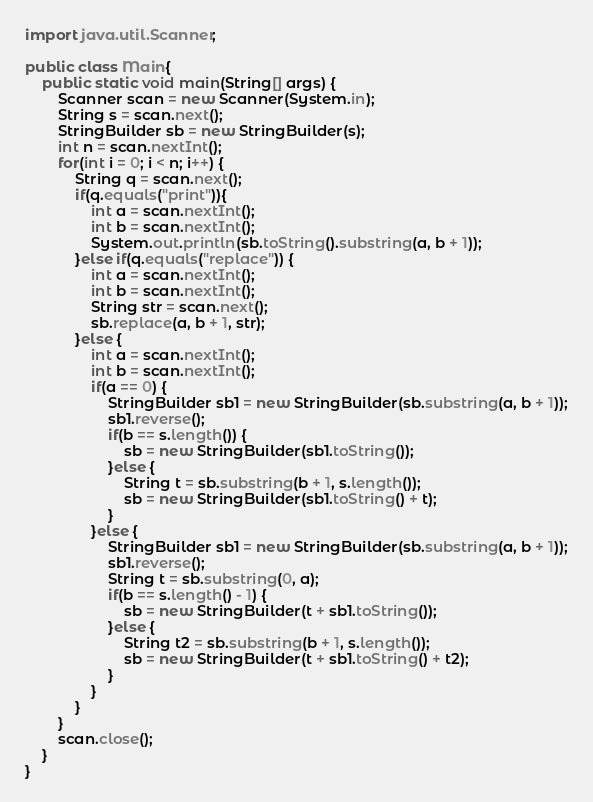Convert code to text. <code><loc_0><loc_0><loc_500><loc_500><_Java_>import java.util.Scanner;

public class Main{
	public static void main(String[] args) {
		Scanner scan = new Scanner(System.in);
		String s = scan.next();
		StringBuilder sb = new StringBuilder(s);
		int n = scan.nextInt();
		for(int i = 0; i < n; i++) {
			String q = scan.next();
			if(q.equals("print")){
				int a = scan.nextInt();
				int b = scan.nextInt();
				System.out.println(sb.toString().substring(a, b + 1));
			}else if(q.equals("replace")) {
				int a = scan.nextInt();
				int b = scan.nextInt();
				String str = scan.next();
				sb.replace(a, b + 1, str);
			}else {
				int a = scan.nextInt();
				int b = scan.nextInt();
				if(a == 0) {
					StringBuilder sb1 = new StringBuilder(sb.substring(a, b + 1));
					sb1.reverse();
					if(b == s.length()) {
						sb = new StringBuilder(sb1.toString());
					}else {
						String t = sb.substring(b + 1, s.length());
						sb = new StringBuilder(sb1.toString() + t);
					}
				}else {
					StringBuilder sb1 = new StringBuilder(sb.substring(a, b + 1));
					sb1.reverse();
					String t = sb.substring(0, a);
					if(b == s.length() - 1) {
						sb = new StringBuilder(t + sb1.toString());
					}else {
						String t2 = sb.substring(b + 1, s.length());
						sb = new StringBuilder(t + sb1.toString() + t2);
					}
				}
			}
		}
		scan.close();
	}
}
</code> 